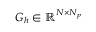<formula> <loc_0><loc_0><loc_500><loc_500>G _ { h } \in \mathbb { R } ^ { N \times N _ { p } }</formula> 